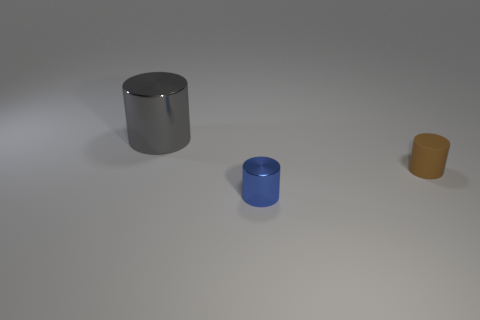How many things are either cyan balls or gray things?
Offer a terse response. 1. What color is the other thing that is the same size as the brown rubber object?
Offer a very short reply. Blue. There is a large thing; is it the same shape as the small thing left of the rubber thing?
Your response must be concise. Yes. What number of objects are either cylinders to the left of the blue thing or tiny cylinders in front of the matte object?
Offer a terse response. 2. The metallic thing in front of the large gray object has what shape?
Make the answer very short. Cylinder. Do the shiny object behind the blue cylinder and the blue thing have the same shape?
Ensure brevity in your answer.  Yes. What number of objects are tiny cylinders that are in front of the tiny brown cylinder or small yellow cylinders?
Ensure brevity in your answer.  1. What color is the other matte thing that is the same shape as the blue object?
Ensure brevity in your answer.  Brown. Is there anything else of the same color as the small metallic cylinder?
Keep it short and to the point. No. How big is the metallic thing that is in front of the brown matte cylinder?
Ensure brevity in your answer.  Small. 